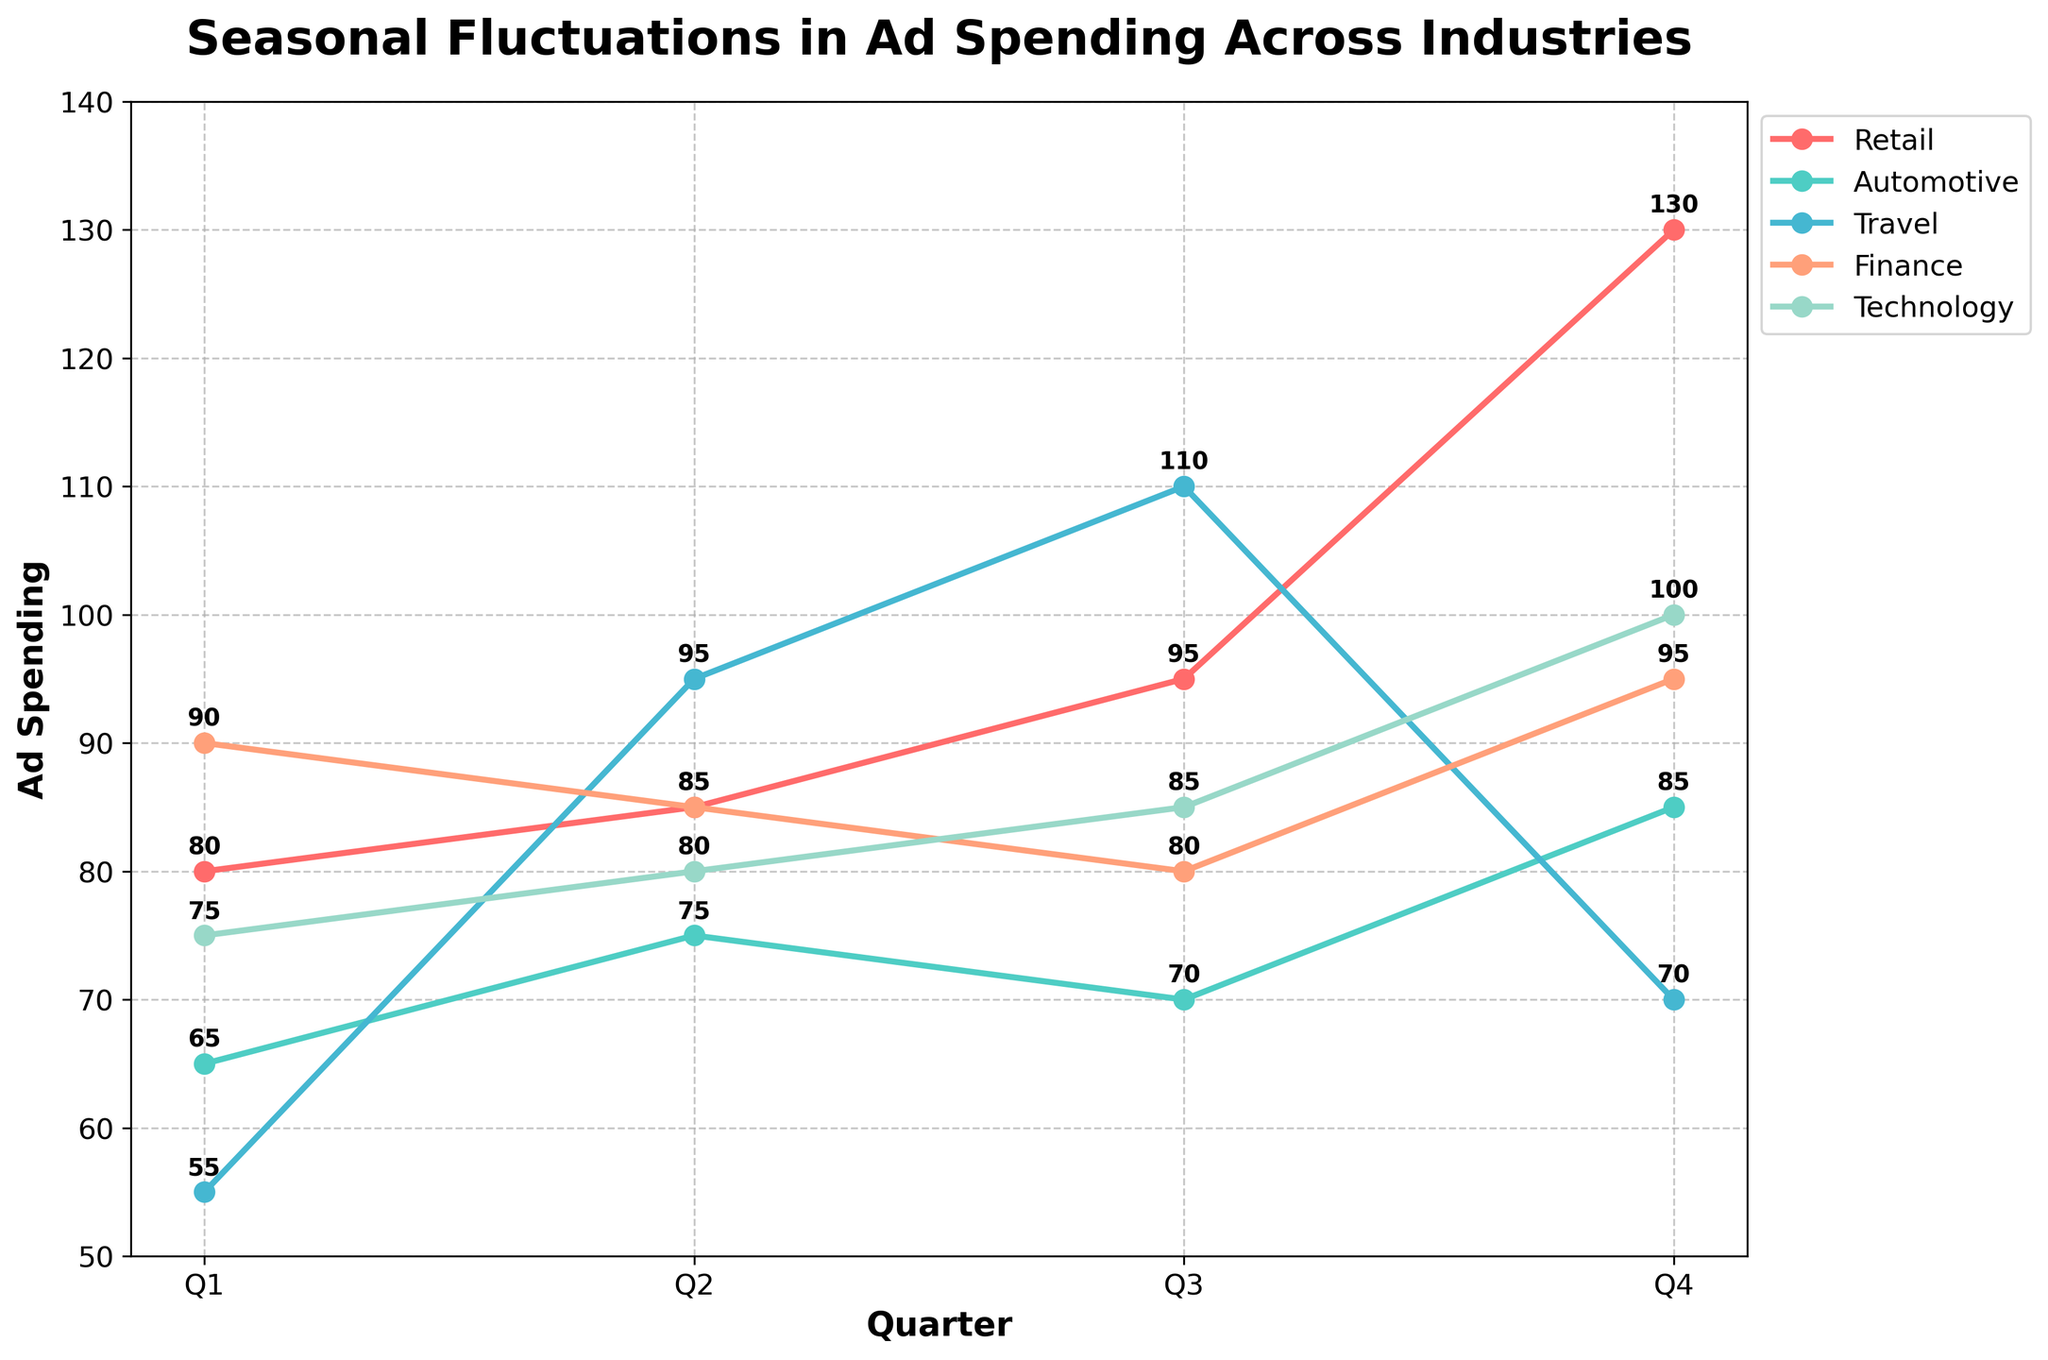What is the highest ad spending for the Retail industry shown on the graph? The highest ad spending for the Retail industry can be determined by observing the peaks in the Retail line plotted on the graph. The highest peak corresponds to Q4 with a value of 130.
Answer: 130 Which industry shows the most significant increase in ad spending from Q1 to Q4? To find the most significant increase, calculate the difference between Q4 and Q1 spending for each industry. Retail: 130 - 80 = 50, Automotive: 85 - 65 = 20, Travel: 70 - 55 = 15, Finance: 95 - 90 = 5, Technology: 100 - 75 = 25. The Retail industry has the largest increase.
Answer: Retail Which quarter shows the highest total ad spending across all industries? Sum the ad spending for each quarter: Q1: 80+65+55+90+75 = 365, Q2: 85+75+95+85+80 = 420, Q3: 95+70+110+80+85 = 440, Q4: 130+85+70+95+100 = 480. Q4 has the highest total ad spending.
Answer: Q4 How does ad spending in the Finance industry change throughout the quarters? Observe the changes in the Finance industry line. Starts at 90 in Q1, drops to 85 in Q2, slightly decreases to 80 in Q3, and rises back to 95 in Q4. Thus, it decreases first and then increases.
Answer: Decreases then increases Which industry has the smallest variation in ad spending throughout the year? Calculate the range (max value - min value) for each industry: Retail: 130-80=50, Automotive: 85-65=20, Travel: 110-55=55, Finance: 95-80=15, Technology: 100-75=25. The Finance industry has the smallest variation.
Answer: Finance In which quarter did ad spending for the Technology industry reach 85? Look at the Technology line and see which quarter has an ad spending value of 85. It occurs in Q3.
Answer: Q3 Between Q2 and Q3, which industry had the largest increase in ad spending? Calculate the change for each industry from Q2 to Q3: Retail: 95-85=10, Automotive: 70-75=(-5), Travel: 110-95=15, Finance: 80-85=(-5), Technology: 85-80=5. The Travel industry has the largest increase.
Answer: Travel Is there any quarter where all industries show an increase in ad spending compared to the previous quarter? Compare each industry’s spending from one quarter to the next and check for simultaneous increases: Q1 to Q2: Retail increases, Automotive increases, Travel increases, Finance decreases, Technology increases – not all increased. Q2 to Q3: Retail increases, Automotive decreases, Travel increases, Finance decreases, Technology remains – not all increased. Q3 to Q4: Retail increases, Automotive increases, Travel decreases, Finance increases, Technology increases – not all increased. Therefore, no quarter has all industries increasing simultaneously.
Answer: No 